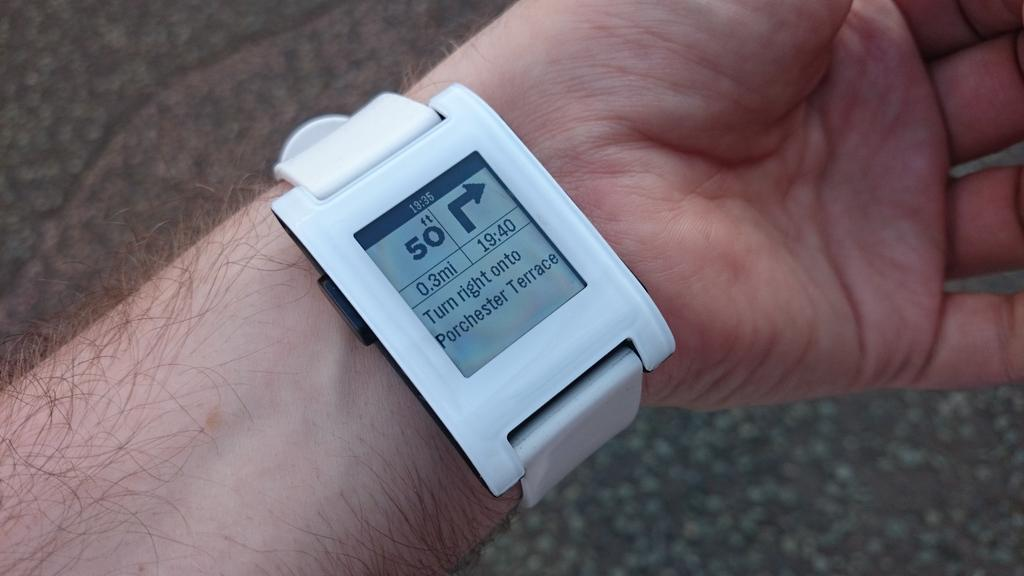What object is visible on a person's hand in the image? There is a watch on a person's hand in the image. What is displayed on the screen of the watch? There is a symbol and some text on the screen of the watch. What type of crown is being worn by the person in the image? There is no crown visible in the image; the focus is on the watch. 